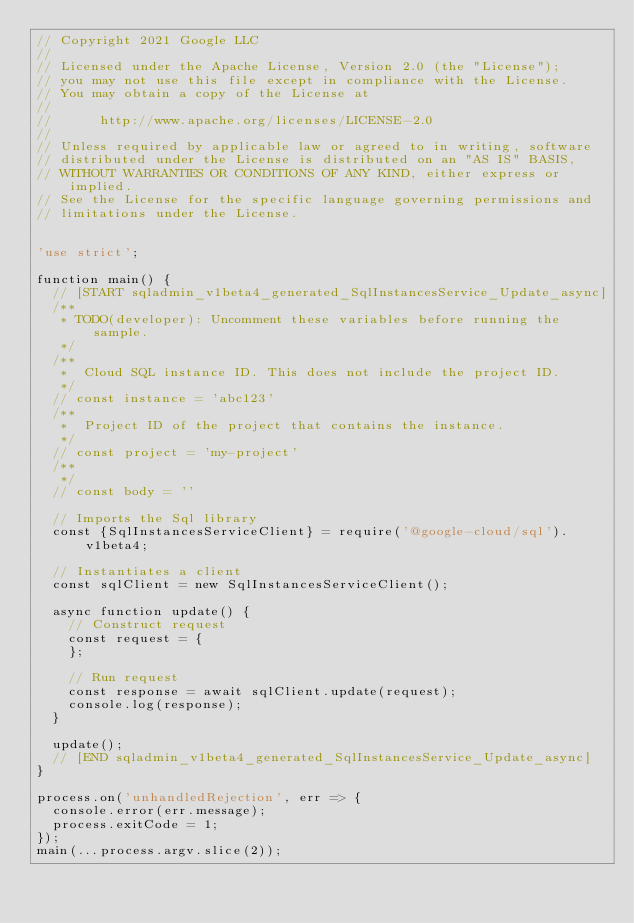Convert code to text. <code><loc_0><loc_0><loc_500><loc_500><_JavaScript_>// Copyright 2021 Google LLC
//
// Licensed under the Apache License, Version 2.0 (the "License");
// you may not use this file except in compliance with the License.
// You may obtain a copy of the License at
//
//      http://www.apache.org/licenses/LICENSE-2.0
//
// Unless required by applicable law or agreed to in writing, software
// distributed under the License is distributed on an "AS IS" BASIS,
// WITHOUT WARRANTIES OR CONDITIONS OF ANY KIND, either express or implied.
// See the License for the specific language governing permissions and
// limitations under the License.


'use strict';

function main() {
  // [START sqladmin_v1beta4_generated_SqlInstancesService_Update_async]
  /**
   * TODO(developer): Uncomment these variables before running the sample.
   */
  /**
   *  Cloud SQL instance ID. This does not include the project ID.
   */
  // const instance = 'abc123'
  /**
   *  Project ID of the project that contains the instance.
   */
  // const project = 'my-project'
  /**
   */
  // const body = ''

  // Imports the Sql library
  const {SqlInstancesServiceClient} = require('@google-cloud/sql').v1beta4;

  // Instantiates a client
  const sqlClient = new SqlInstancesServiceClient();

  async function update() {
    // Construct request
    const request = {
    };

    // Run request
    const response = await sqlClient.update(request);
    console.log(response);
  }

  update();
  // [END sqladmin_v1beta4_generated_SqlInstancesService_Update_async]
}

process.on('unhandledRejection', err => {
  console.error(err.message);
  process.exitCode = 1;
});
main(...process.argv.slice(2));
</code> 